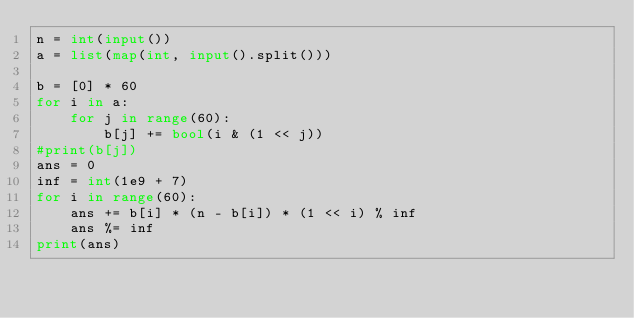<code> <loc_0><loc_0><loc_500><loc_500><_Python_>n = int(input())
a = list(map(int, input().split()))

b = [0] * 60
for i in a:
    for j in range(60):
        b[j] += bool(i & (1 << j))
#print(b[j])
ans = 0
inf = int(1e9 + 7)
for i in range(60):
    ans += b[i] * (n - b[i]) * (1 << i) % inf
    ans %= inf
print(ans)</code> 